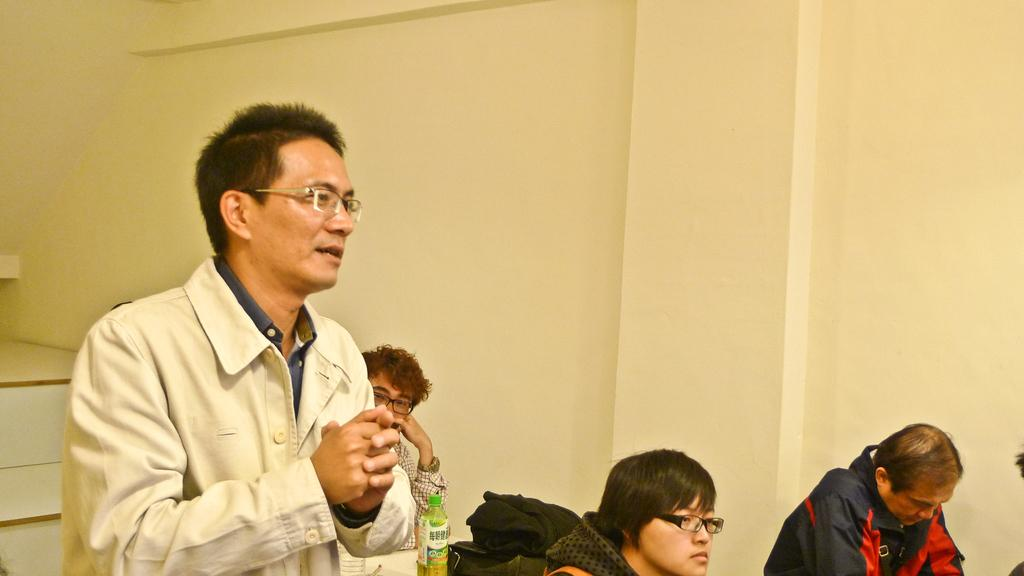How many people are in the image? There are people in the image, but the exact number is not specified. Can you describe the man in the image? There is a man standing among the people in the image. What objects can be seen in the image besides the people? There is a bottle, a bag, and cloth in the image. What is visible in the background of the image? There is a wall in the background of the image. What type of operation is being performed on the sidewalk in the image? There is no sidewalk or operation present in the image. How many circles can be seen in the image? There is no mention of circles in the image. 